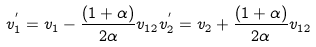Convert formula to latex. <formula><loc_0><loc_0><loc_500><loc_500>v _ { 1 } ^ { ^ { \prime } } = v _ { 1 } - \frac { ( 1 + \alpha ) } { 2 \alpha } v _ { 1 2 } v _ { 2 } ^ { ^ { \prime } } = v _ { 2 } + \frac { ( 1 + \alpha ) } { 2 \alpha } v _ { 1 2 }</formula> 